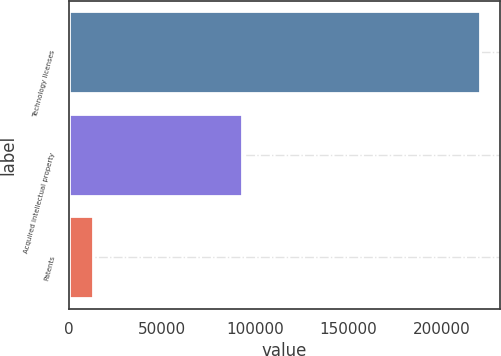Convert chart. <chart><loc_0><loc_0><loc_500><loc_500><bar_chart><fcel>Technology licenses<fcel>Acquired intellectual property<fcel>Patents<nl><fcel>220628<fcel>92778<fcel>12730<nl></chart> 